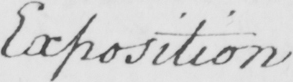Transcribe the text shown in this historical manuscript line. Exposition 